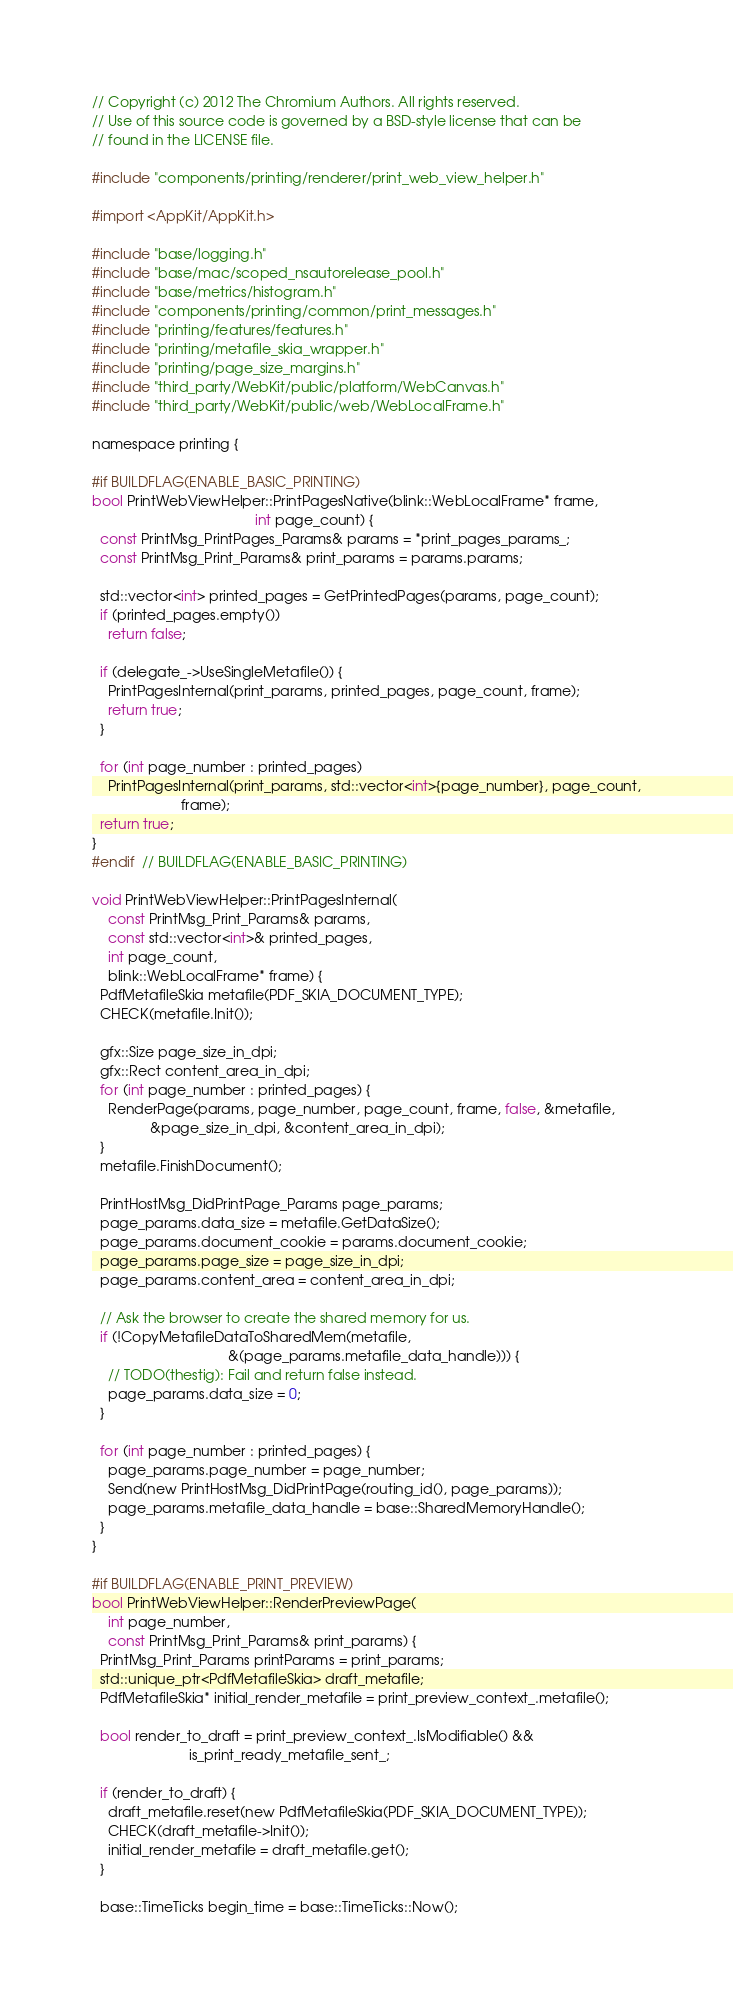<code> <loc_0><loc_0><loc_500><loc_500><_ObjectiveC_>// Copyright (c) 2012 The Chromium Authors. All rights reserved.
// Use of this source code is governed by a BSD-style license that can be
// found in the LICENSE file.

#include "components/printing/renderer/print_web_view_helper.h"

#import <AppKit/AppKit.h>

#include "base/logging.h"
#include "base/mac/scoped_nsautorelease_pool.h"
#include "base/metrics/histogram.h"
#include "components/printing/common/print_messages.h"
#include "printing/features/features.h"
#include "printing/metafile_skia_wrapper.h"
#include "printing/page_size_margins.h"
#include "third_party/WebKit/public/platform/WebCanvas.h"
#include "third_party/WebKit/public/web/WebLocalFrame.h"

namespace printing {

#if BUILDFLAG(ENABLE_BASIC_PRINTING)
bool PrintWebViewHelper::PrintPagesNative(blink::WebLocalFrame* frame,
                                          int page_count) {
  const PrintMsg_PrintPages_Params& params = *print_pages_params_;
  const PrintMsg_Print_Params& print_params = params.params;

  std::vector<int> printed_pages = GetPrintedPages(params, page_count);
  if (printed_pages.empty())
    return false;

  if (delegate_->UseSingleMetafile()) {
    PrintPagesInternal(print_params, printed_pages, page_count, frame);
    return true;
  }

  for (int page_number : printed_pages)
    PrintPagesInternal(print_params, std::vector<int>{page_number}, page_count,
                       frame);
  return true;
}
#endif  // BUILDFLAG(ENABLE_BASIC_PRINTING)

void PrintWebViewHelper::PrintPagesInternal(
    const PrintMsg_Print_Params& params,
    const std::vector<int>& printed_pages,
    int page_count,
    blink::WebLocalFrame* frame) {
  PdfMetafileSkia metafile(PDF_SKIA_DOCUMENT_TYPE);
  CHECK(metafile.Init());

  gfx::Size page_size_in_dpi;
  gfx::Rect content_area_in_dpi;
  for (int page_number : printed_pages) {
    RenderPage(params, page_number, page_count, frame, false, &metafile,
               &page_size_in_dpi, &content_area_in_dpi);
  }
  metafile.FinishDocument();

  PrintHostMsg_DidPrintPage_Params page_params;
  page_params.data_size = metafile.GetDataSize();
  page_params.document_cookie = params.document_cookie;
  page_params.page_size = page_size_in_dpi;
  page_params.content_area = content_area_in_dpi;

  // Ask the browser to create the shared memory for us.
  if (!CopyMetafileDataToSharedMem(metafile,
                                   &(page_params.metafile_data_handle))) {
    // TODO(thestig): Fail and return false instead.
    page_params.data_size = 0;
  }

  for (int page_number : printed_pages) {
    page_params.page_number = page_number;
    Send(new PrintHostMsg_DidPrintPage(routing_id(), page_params));
    page_params.metafile_data_handle = base::SharedMemoryHandle();
  }
}

#if BUILDFLAG(ENABLE_PRINT_PREVIEW)
bool PrintWebViewHelper::RenderPreviewPage(
    int page_number,
    const PrintMsg_Print_Params& print_params) {
  PrintMsg_Print_Params printParams = print_params;
  std::unique_ptr<PdfMetafileSkia> draft_metafile;
  PdfMetafileSkia* initial_render_metafile = print_preview_context_.metafile();

  bool render_to_draft = print_preview_context_.IsModifiable() &&
                         is_print_ready_metafile_sent_;

  if (render_to_draft) {
    draft_metafile.reset(new PdfMetafileSkia(PDF_SKIA_DOCUMENT_TYPE));
    CHECK(draft_metafile->Init());
    initial_render_metafile = draft_metafile.get();
  }

  base::TimeTicks begin_time = base::TimeTicks::Now();</code> 